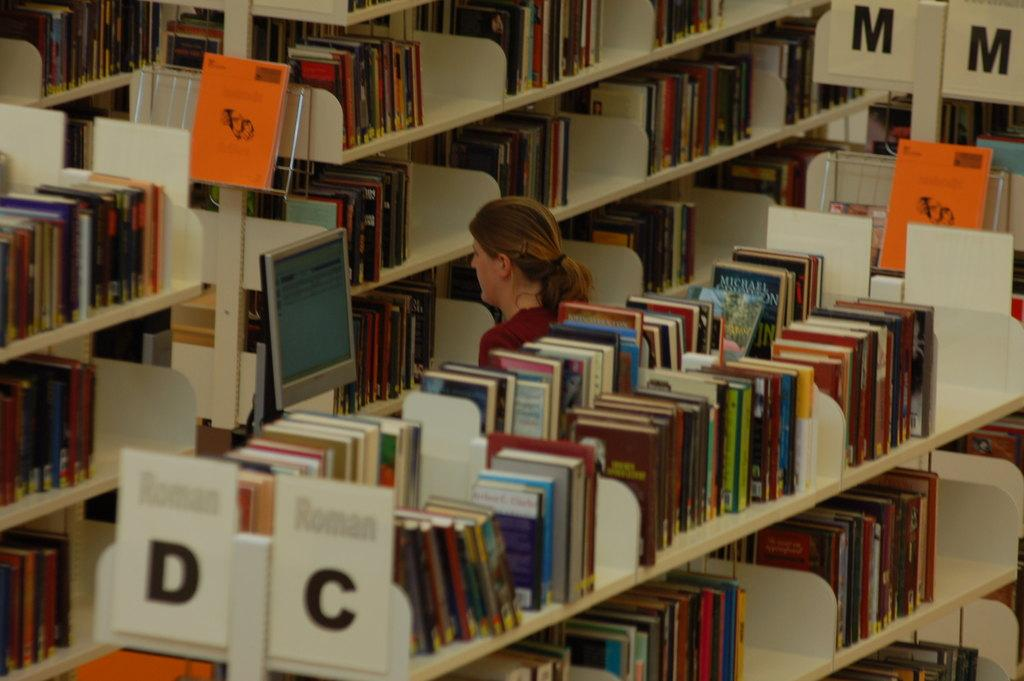<image>
Provide a brief description of the given image. A library isle with shelves of books for letters D,C and M. 